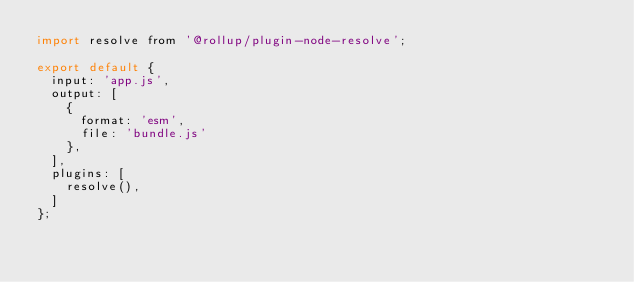Convert code to text. <code><loc_0><loc_0><loc_500><loc_500><_JavaScript_>import resolve from '@rollup/plugin-node-resolve';

export default {
  input: 'app.js',
  output: [
    {
      format: 'esm',
      file: 'bundle.js'
    },
  ],
  plugins: [
    resolve(),
  ]
};</code> 